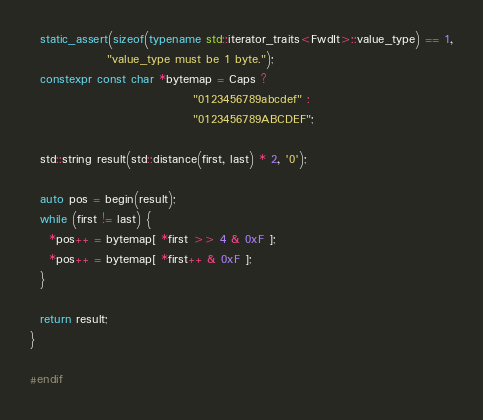Convert code to text. <code><loc_0><loc_0><loc_500><loc_500><_C++_>  static_assert(sizeof(typename std::iterator_traits<FwdIt>::value_type) == 1,
                "value_type must be 1 byte.");
  constexpr const char *bytemap = Caps ?
                                  "0123456789abcdef" :
                                  "0123456789ABCDEF";

  std::string result(std::distance(first, last) * 2, '0');

  auto pos = begin(result);
  while (first != last) {
    *pos++ = bytemap[ *first >> 4 & 0xF ];
    *pos++ = bytemap[ *first++ & 0xF ];
  }

  return result;
}

#endif
</code> 